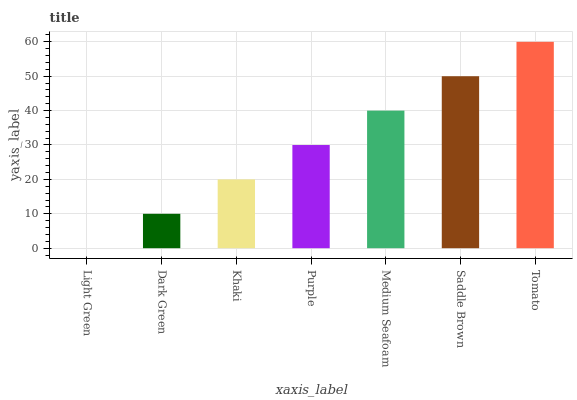Is Light Green the minimum?
Answer yes or no. Yes. Is Tomato the maximum?
Answer yes or no. Yes. Is Dark Green the minimum?
Answer yes or no. No. Is Dark Green the maximum?
Answer yes or no. No. Is Dark Green greater than Light Green?
Answer yes or no. Yes. Is Light Green less than Dark Green?
Answer yes or no. Yes. Is Light Green greater than Dark Green?
Answer yes or no. No. Is Dark Green less than Light Green?
Answer yes or no. No. Is Purple the high median?
Answer yes or no. Yes. Is Purple the low median?
Answer yes or no. Yes. Is Light Green the high median?
Answer yes or no. No. Is Khaki the low median?
Answer yes or no. No. 